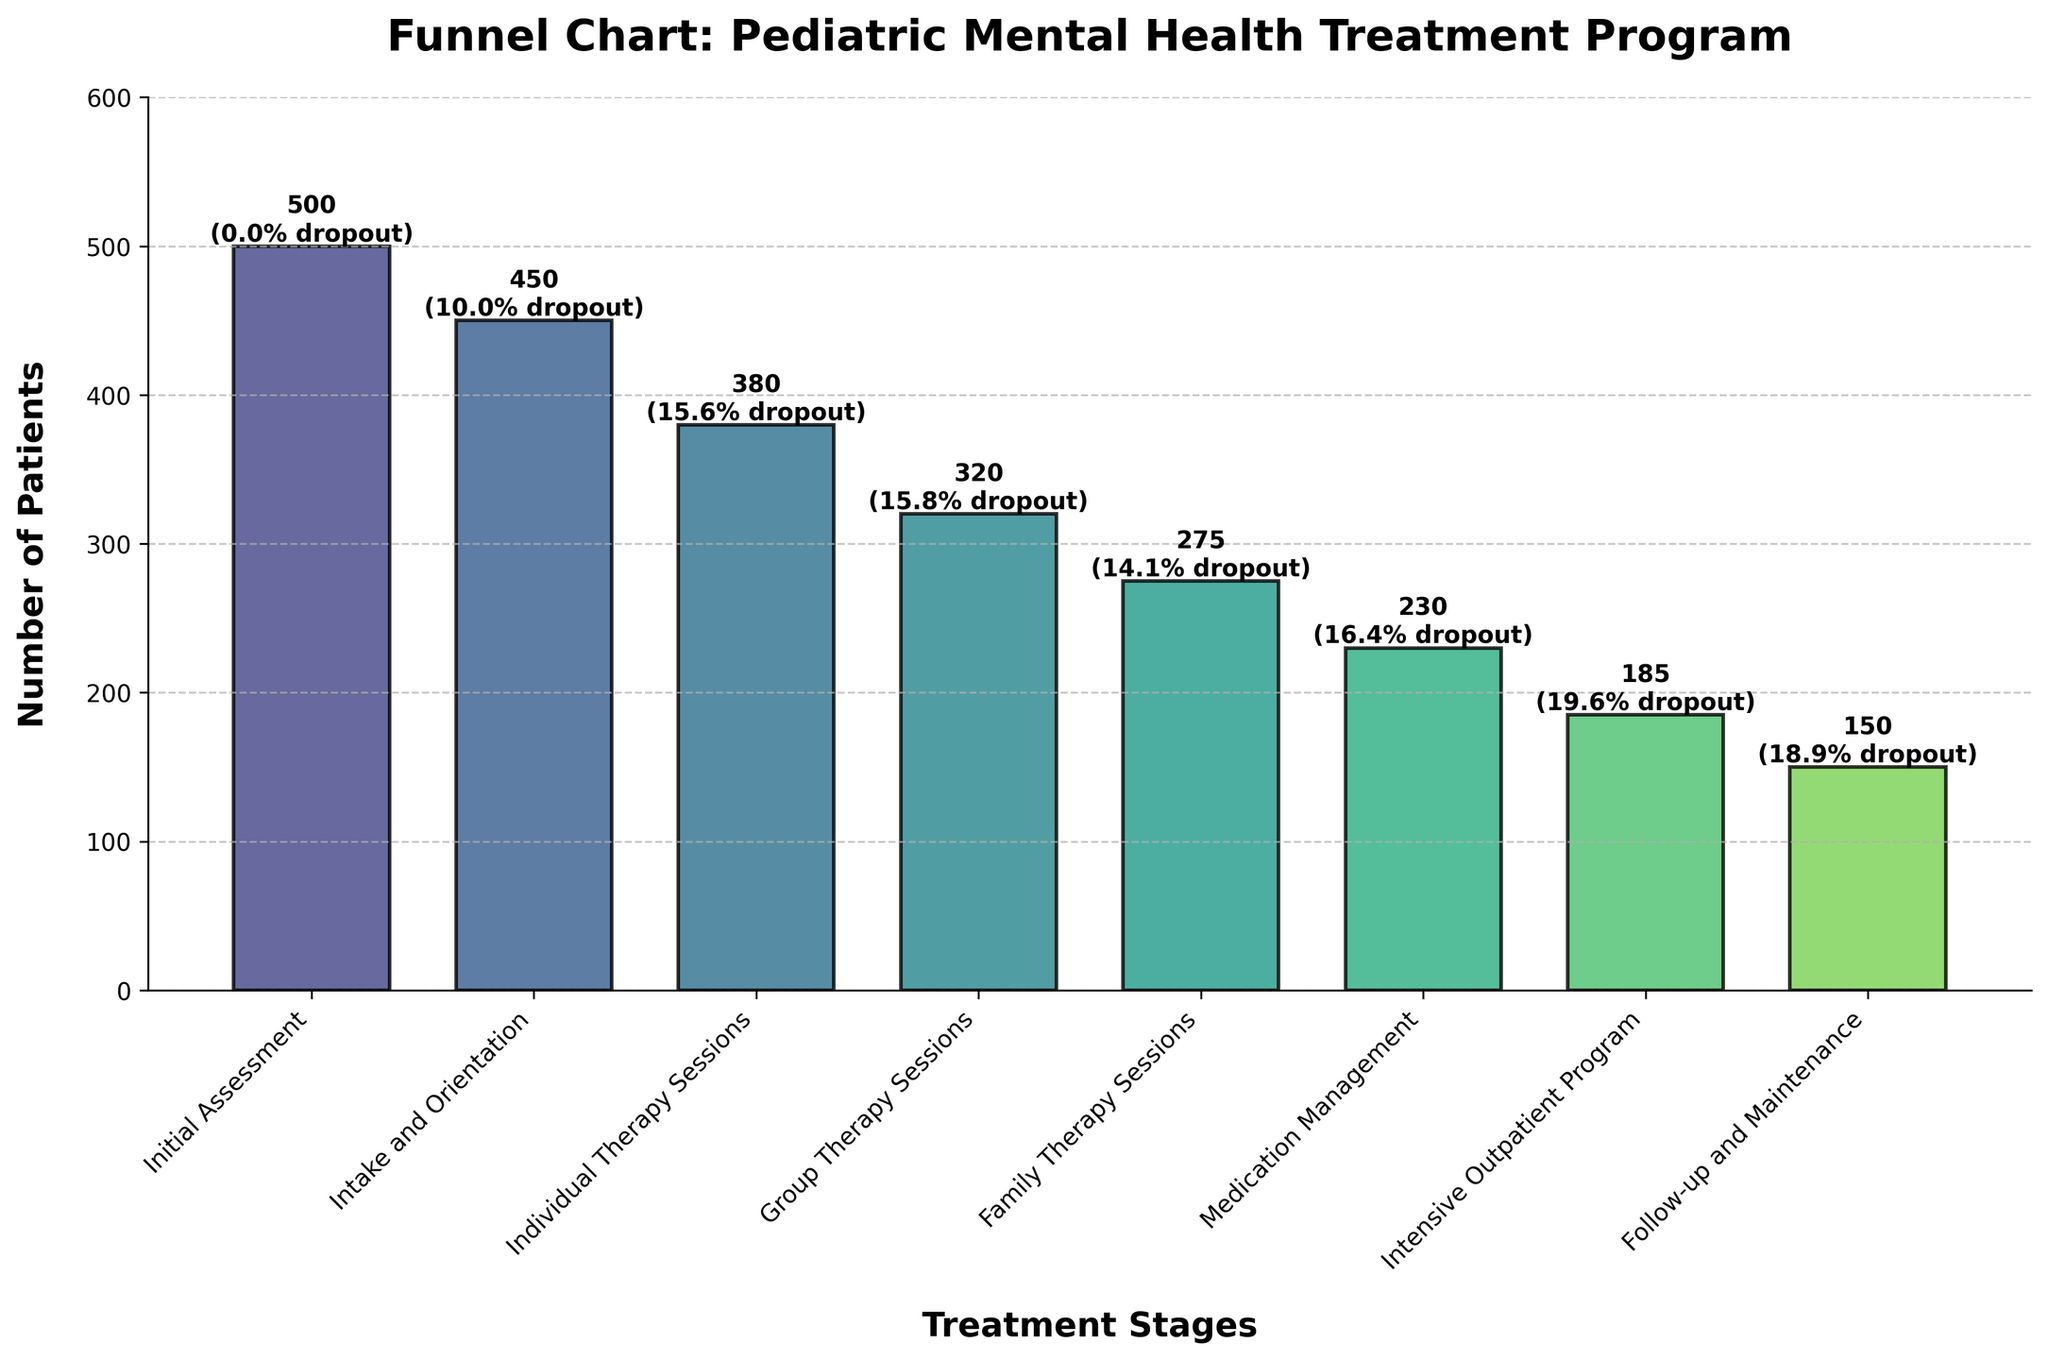How many patients started with the Initial Assessment stage? We look at the "Initial Assessment" stage on the x-axis and find the corresponding bar, which shows the number 500.
Answer: 500 What's the dropout rate for the Individual Therapy Sessions stage? We look at the "Individual Therapy Sessions" stage on the x-axis and find the dropout rate written above the bar, which shows 15.6%.
Answer: 15.6% Which stage has the highest dropout rate? By comparing the dropout rates written above each bar, we see that the "Intensive Outpatient Program" stage has the highest dropout rate of 19.6%.
Answer: Intensive Outpatient Program Compare the number of patients between the Intake and Orientation and Family Therapy Sessions stages. Which stage has fewer patients? We look at the bars for "Intake and Orientation" (450 patients) and "Family Therapy Sessions" (275 patients). The Family Therapy Sessions stage has fewer patients.
Answer: Family Therapy Sessions What's the total number of patients from the Individual Therapy Sessions, Group Therapy Sessions, and Family Therapy Sessions combined? Add the number of patients from these stages: 380 (Individual Therapy Sessions) + 320 (Group Therapy Sessions) + 275 (Family Therapy Sessions) = 975 patients.
Answer: 975 What is the number of patients at the Follow-up and Maintenance stage compared to the Medication Management stage? We compare the numbers above the bars for "Follow-up and Maintenance" (150 patients) and "Medication Management" (230 patients), showing that the Follow-up and Maintenance stage has fewer patients.
Answer: Follow-up and Maintenance What is the average dropout rate across all stages? Convert dropdown percentages to decimals (divide each by 100), sum them up, and divide by the number of stages (excluding "Initial Assessment" since its rate is 0%): (10% + 15.6% + 15.8% + 14.1% + 16.4% + 19.6% + 18.9%)/7 ≈ 16%.
Answer: 16% Which stage experiences the second-highest patient loss in number from the previous stage? Calculate the differences in the number of patients between consecutive stages: 500-450 = 50, 450-380 = 70, 380-320 = 60, 320-275 = 45, 275-230 = 45, 230-185 = 45, 185-150 = 35. The largest loss is from Intake and Orientation to Individual Therapy Sessions (70 patients). The second-highest loss is from Individual Therapy Sessions to Group Therapy Sessions (60 patients).
Answer: Individual Therapy Sessions to Group Therapy Sessions 